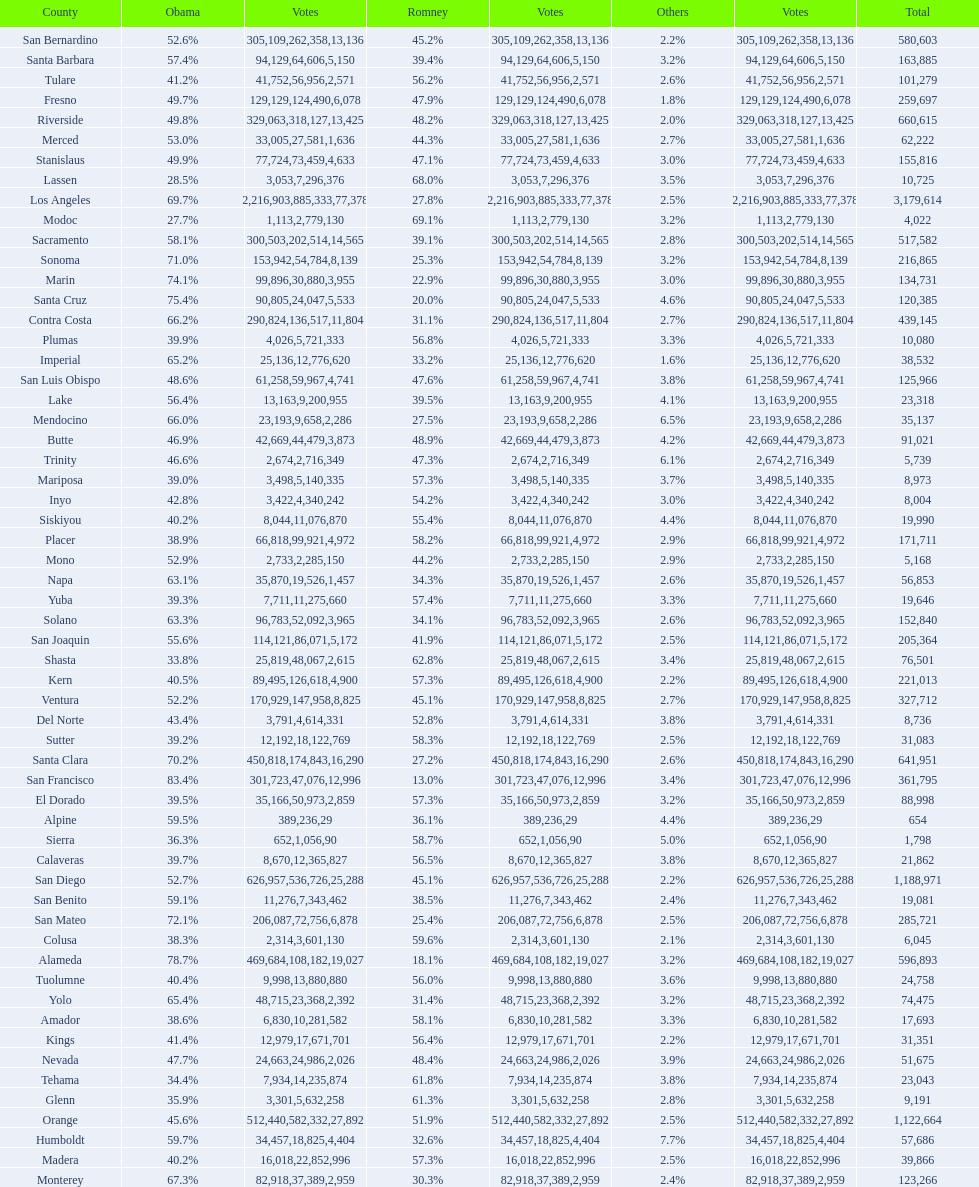Which county had the most total votes? Los Angeles. 